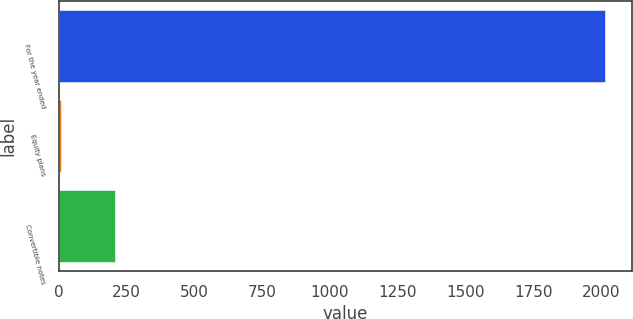Convert chart. <chart><loc_0><loc_0><loc_500><loc_500><bar_chart><fcel>For the year ended<fcel>Equity plans<fcel>Convertible notes<nl><fcel>2014<fcel>7<fcel>207.7<nl></chart> 